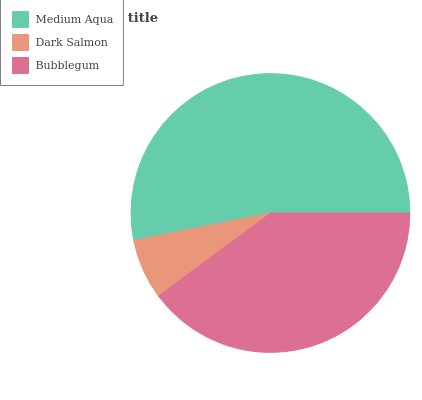Is Dark Salmon the minimum?
Answer yes or no. Yes. Is Medium Aqua the maximum?
Answer yes or no. Yes. Is Bubblegum the minimum?
Answer yes or no. No. Is Bubblegum the maximum?
Answer yes or no. No. Is Bubblegum greater than Dark Salmon?
Answer yes or no. Yes. Is Dark Salmon less than Bubblegum?
Answer yes or no. Yes. Is Dark Salmon greater than Bubblegum?
Answer yes or no. No. Is Bubblegum less than Dark Salmon?
Answer yes or no. No. Is Bubblegum the high median?
Answer yes or no. Yes. Is Bubblegum the low median?
Answer yes or no. Yes. Is Dark Salmon the high median?
Answer yes or no. No. Is Medium Aqua the low median?
Answer yes or no. No. 